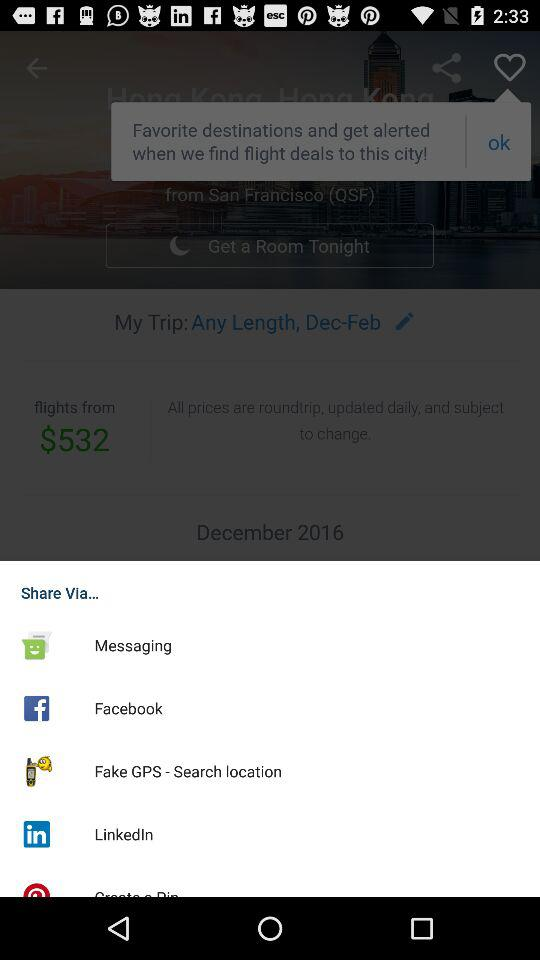Which destinations are selected as favorites?
When the provided information is insufficient, respond with <no answer>. <no answer> 